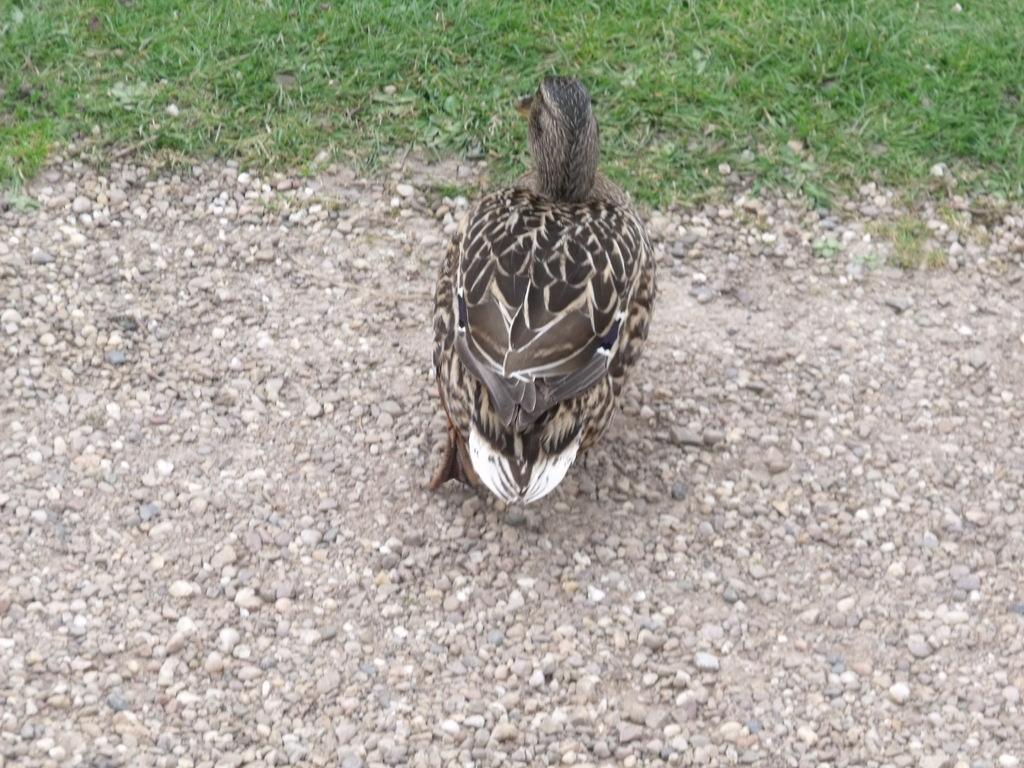In one or two sentences, can you explain what this image depicts? In the image we can see a bird gray and white in color, this is a sand and a grass. 